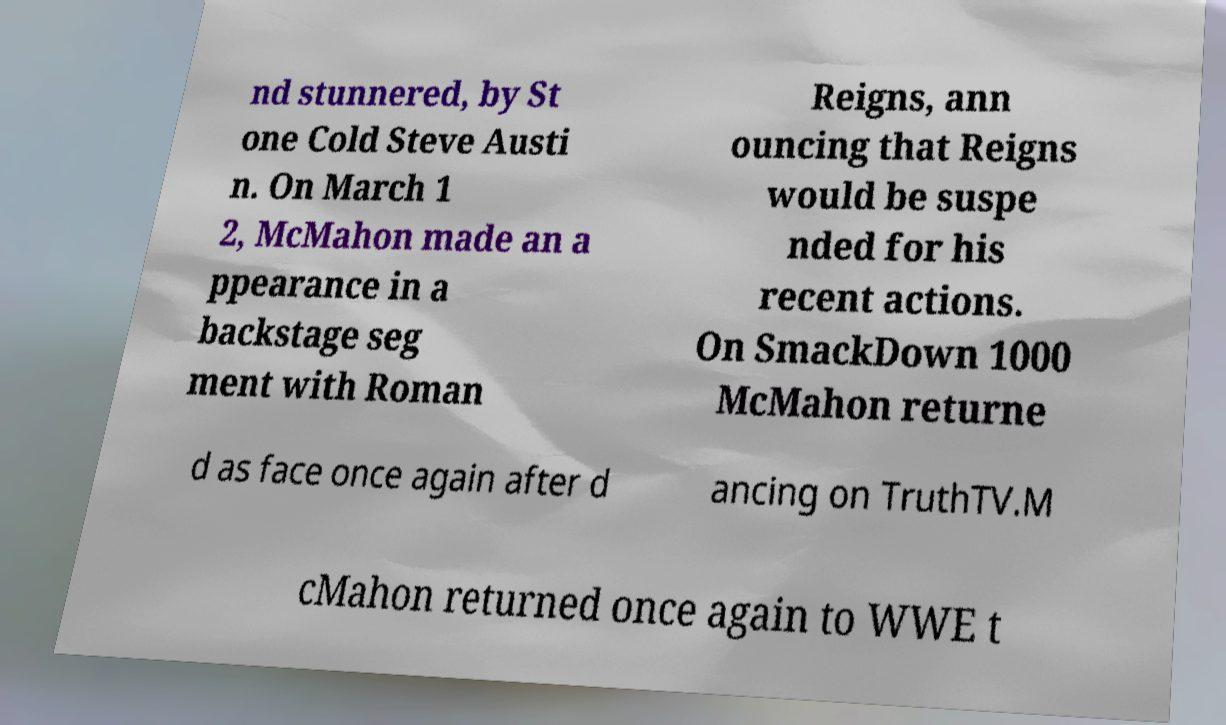Please identify and transcribe the text found in this image. nd stunnered, by St one Cold Steve Austi n. On March 1 2, McMahon made an a ppearance in a backstage seg ment with Roman Reigns, ann ouncing that Reigns would be suspe nded for his recent actions. On SmackDown 1000 McMahon returne d as face once again after d ancing on TruthTV.M cMahon returned once again to WWE t 